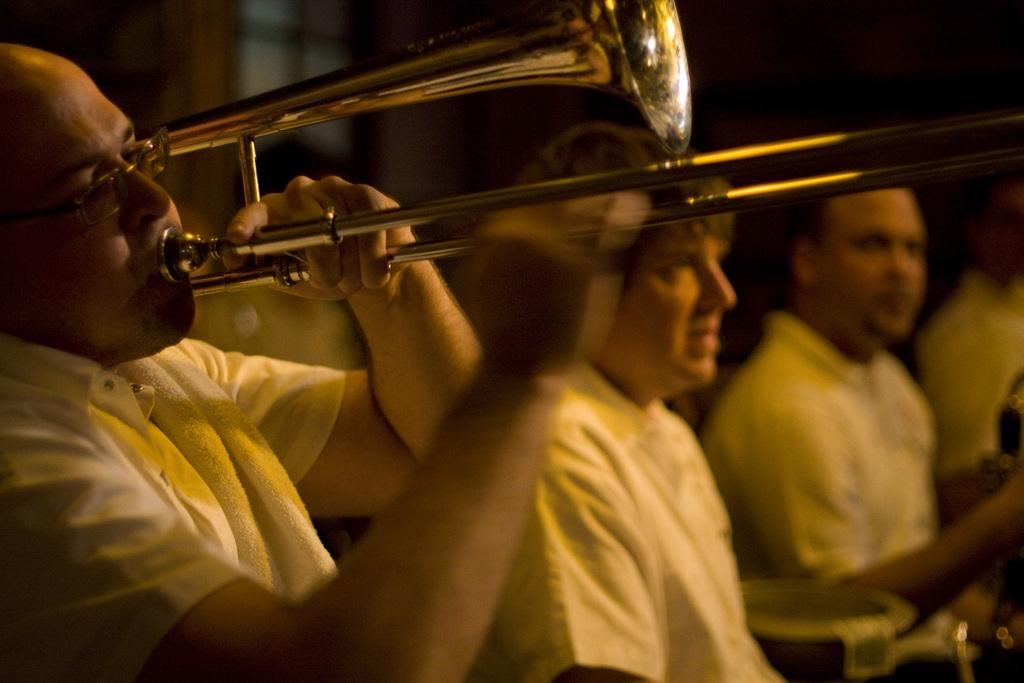What is the person in the image holding? The person in the image is holding a trumpet. What are the other people in the image doing? The other people in the image are sitting beside the person holding the trumpet. What flavor of toy can be seen in the image? There are no toys or flavors present in the image. 